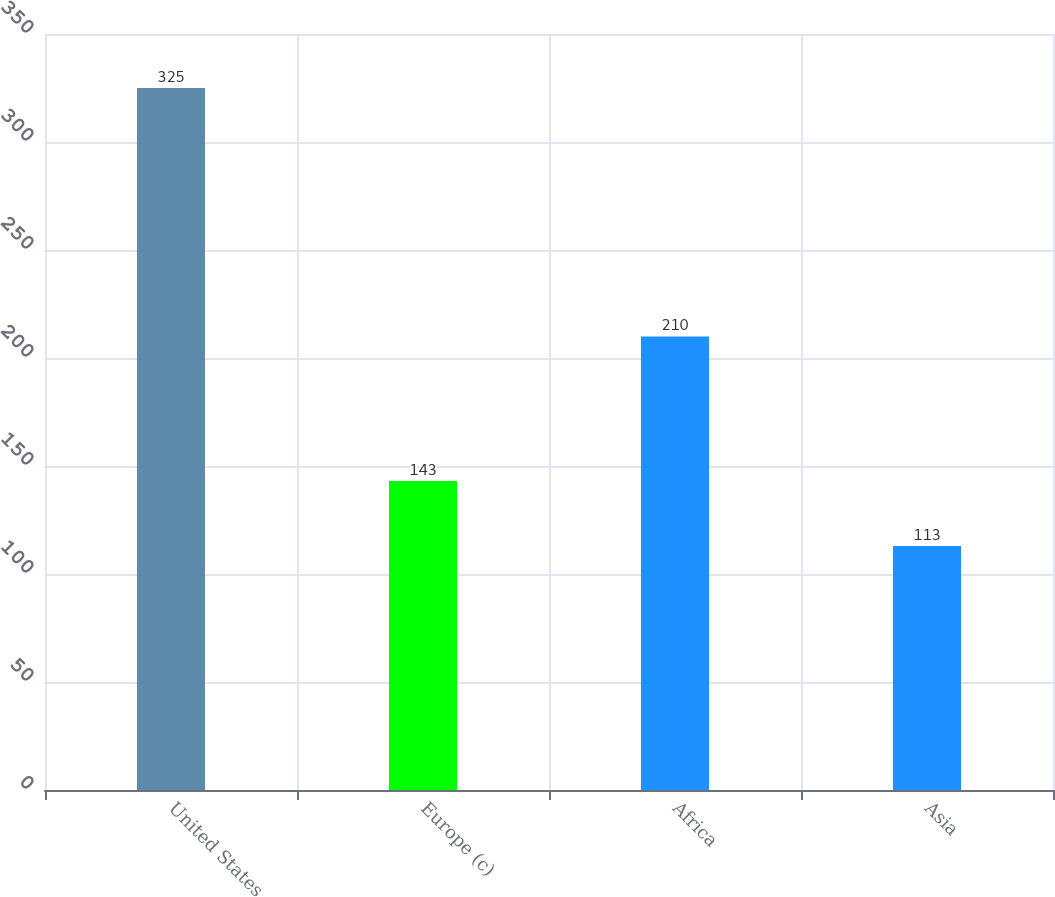Convert chart to OTSL. <chart><loc_0><loc_0><loc_500><loc_500><bar_chart><fcel>United States<fcel>Europe (c)<fcel>Africa<fcel>Asia<nl><fcel>325<fcel>143<fcel>210<fcel>113<nl></chart> 